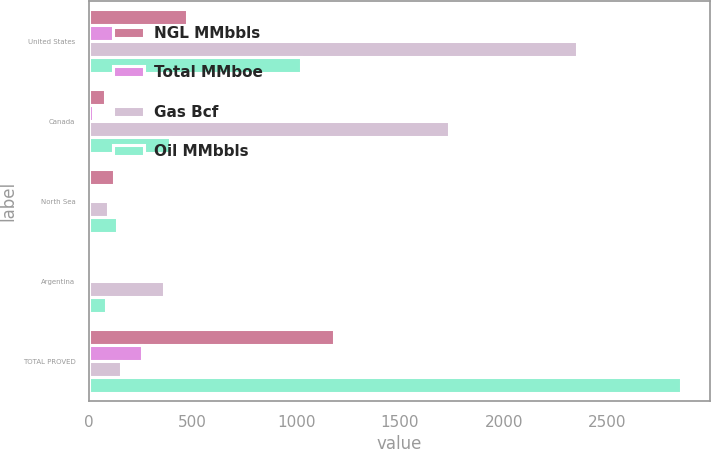<chart> <loc_0><loc_0><loc_500><loc_500><stacked_bar_chart><ecel><fcel>United States<fcel>Canada<fcel>North Sea<fcel>Argentina<fcel>TOTAL PROVED<nl><fcel>NGL MMbbls<fcel>474<fcel>80<fcel>120<fcel>16<fcel>1183<nl><fcel>Total MMboe<fcel>155<fcel>22<fcel>2<fcel>5<fcel>258<nl><fcel>Gas Bcf<fcel>2354<fcel>1735<fcel>93<fcel>365<fcel>155<nl><fcel>Oil MMbbls<fcel>1021<fcel>391<fcel>138<fcel>82<fcel>2852<nl></chart> 